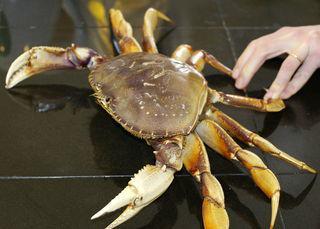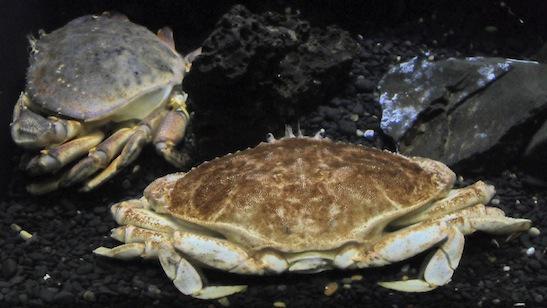The first image is the image on the left, the second image is the image on the right. Given the left and right images, does the statement "A bare hand is touching two of a crab's claws in one image." hold true? Answer yes or no. Yes. The first image is the image on the left, the second image is the image on the right. Analyze the images presented: Is the assertion "In at least one image there is a single hand holding two of the crabs legs." valid? Answer yes or no. Yes. 